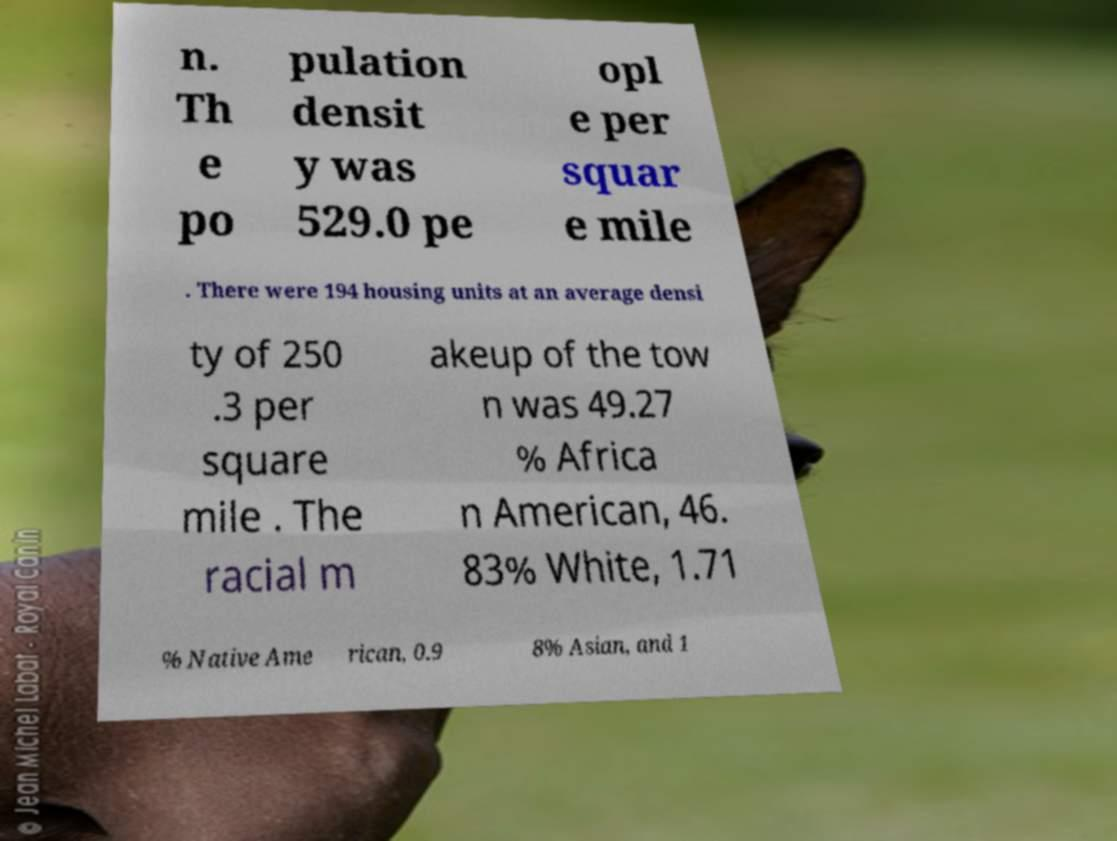I need the written content from this picture converted into text. Can you do that? n. Th e po pulation densit y was 529.0 pe opl e per squar e mile . There were 194 housing units at an average densi ty of 250 .3 per square mile . The racial m akeup of the tow n was 49.27 % Africa n American, 46. 83% White, 1.71 % Native Ame rican, 0.9 8% Asian, and 1 